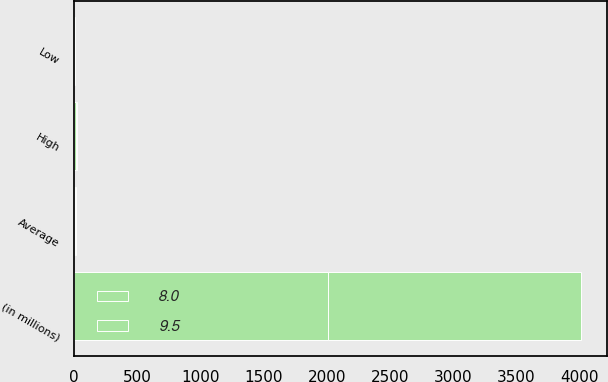<chart> <loc_0><loc_0><loc_500><loc_500><stacked_bar_chart><ecel><fcel>(in millions)<fcel>High<fcel>Average<fcel>Low<nl><fcel>9.5<fcel>2007<fcel>7.2<fcel>5.2<fcel>2.4<nl><fcel>8<fcel>2006<fcel>11.7<fcel>6.1<fcel>1.5<nl></chart> 